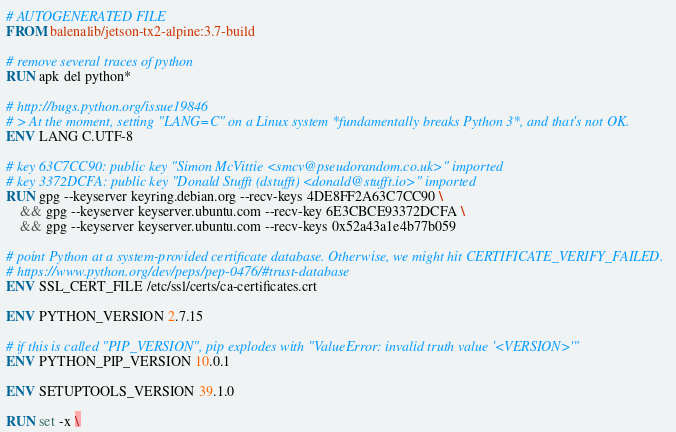<code> <loc_0><loc_0><loc_500><loc_500><_Dockerfile_># AUTOGENERATED FILE
FROM balenalib/jetson-tx2-alpine:3.7-build

# remove several traces of python
RUN apk del python*

# http://bugs.python.org/issue19846
# > At the moment, setting "LANG=C" on a Linux system *fundamentally breaks Python 3*, and that's not OK.
ENV LANG C.UTF-8

# key 63C7CC90: public key "Simon McVittie <smcv@pseudorandom.co.uk>" imported
# key 3372DCFA: public key "Donald Stufft (dstufft) <donald@stufft.io>" imported
RUN gpg --keyserver keyring.debian.org --recv-keys 4DE8FF2A63C7CC90 \
	&& gpg --keyserver keyserver.ubuntu.com --recv-key 6E3CBCE93372DCFA \
	&& gpg --keyserver keyserver.ubuntu.com --recv-keys 0x52a43a1e4b77b059

# point Python at a system-provided certificate database. Otherwise, we might hit CERTIFICATE_VERIFY_FAILED.
# https://www.python.org/dev/peps/pep-0476/#trust-database
ENV SSL_CERT_FILE /etc/ssl/certs/ca-certificates.crt

ENV PYTHON_VERSION 2.7.15

# if this is called "PIP_VERSION", pip explodes with "ValueError: invalid truth value '<VERSION>'"
ENV PYTHON_PIP_VERSION 10.0.1

ENV SETUPTOOLS_VERSION 39.1.0

RUN set -x \</code> 